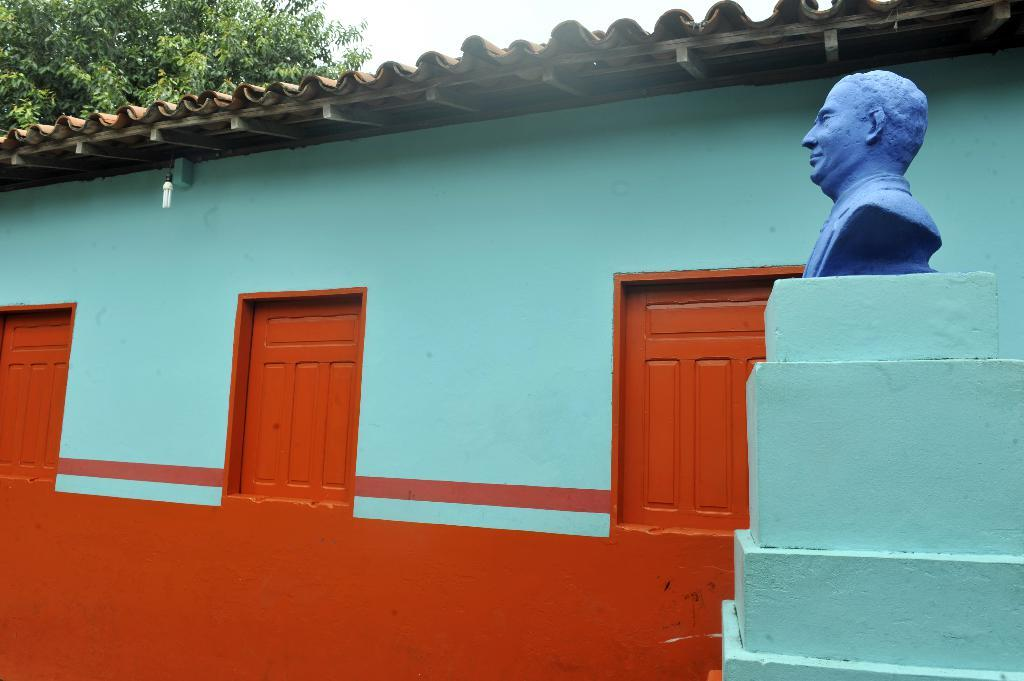What can be seen on the right side of the image? There is a statue on the wall on the right side of the image. What is visible in the background of the image? There are windows visible in the background of the image. What is hanging from the roof at the top of the image? A light is hanging on the roof at the top of the image. What type of vegetation is present in the image? There is a tree in the image. Can you hear any thunder in the image? There is no sound present in the image, so it is not possible to determine if there is thunder. What type of bone is visible in the image? There is no bone present in the image. 